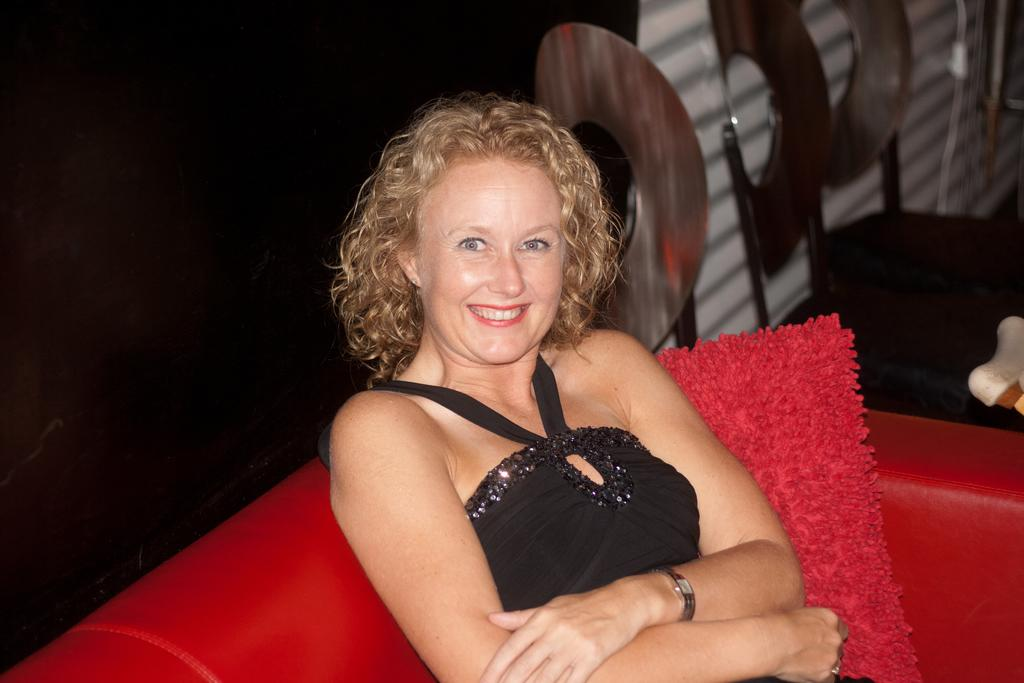Who is present in the image? There is a woman in the image. What is the woman doing in the image? The woman is sitting on a sofa and smiling. Are there any other objects or people visible in the image? There are empty chairs beside the woman. What type of goat can be seen in the image? There is no goat present in the image. What kind of bait is the woman using in the image? The image does not depict any fishing or bait-related activities. 